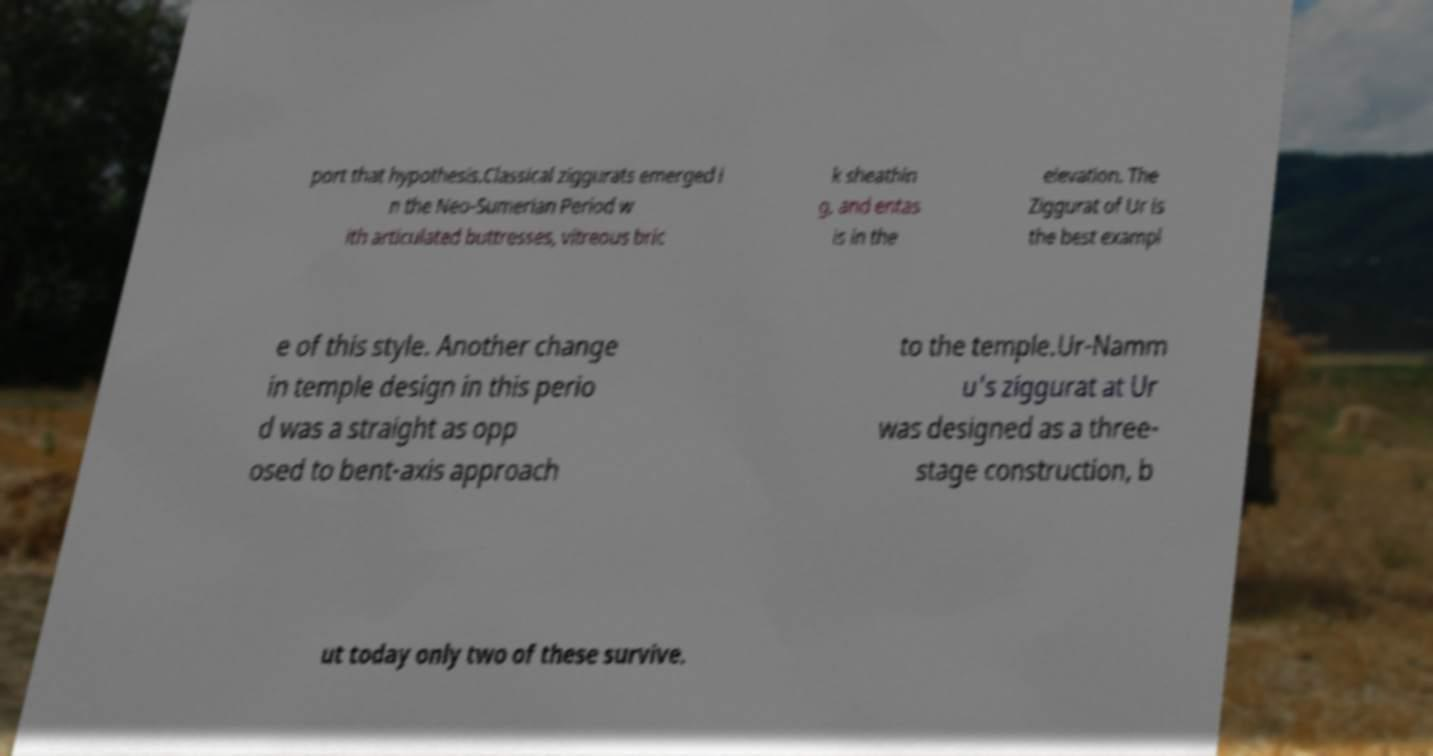For documentation purposes, I need the text within this image transcribed. Could you provide that? port that hypothesis.Classical ziggurats emerged i n the Neo-Sumerian Period w ith articulated buttresses, vitreous bric k sheathin g, and entas is in the elevation. The Ziggurat of Ur is the best exampl e of this style. Another change in temple design in this perio d was a straight as opp osed to bent-axis approach to the temple.Ur-Namm u's ziggurat at Ur was designed as a three- stage construction, b ut today only two of these survive. 